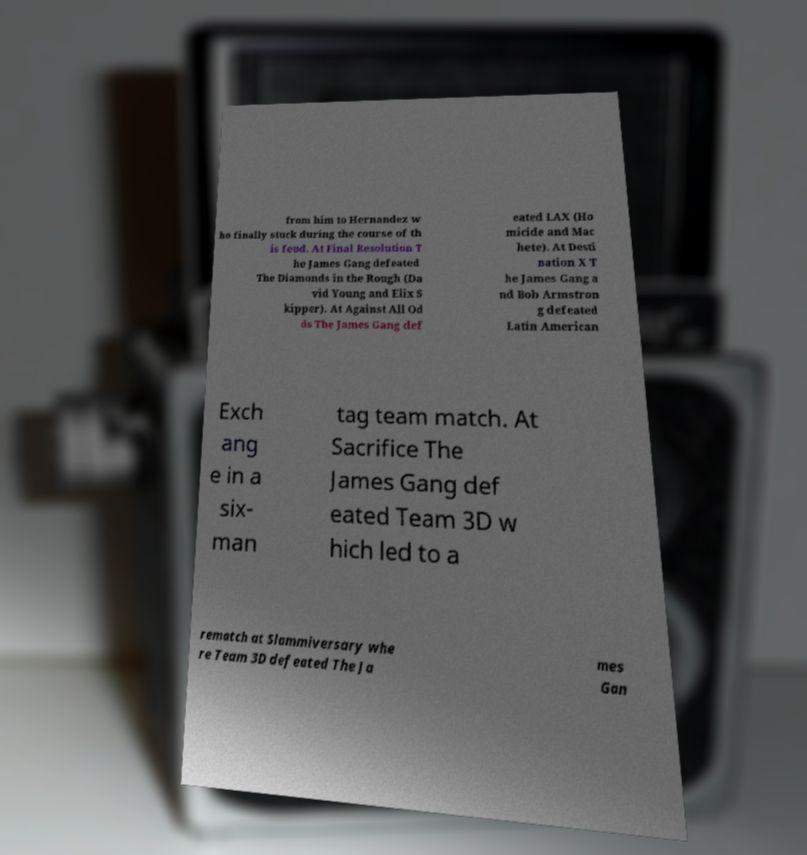Could you extract and type out the text from this image? from him to Hernandez w ho finally stuck during the course of th is feud. At Final Resolution T he James Gang defeated The Diamonds in the Rough (Da vid Young and Elix S kipper). At Against All Od ds The James Gang def eated LAX (Ho micide and Mac hete). At Desti nation X T he James Gang a nd Bob Armstron g defeated Latin American Exch ang e in a six- man tag team match. At Sacrifice The James Gang def eated Team 3D w hich led to a rematch at Slammiversary whe re Team 3D defeated The Ja mes Gan 